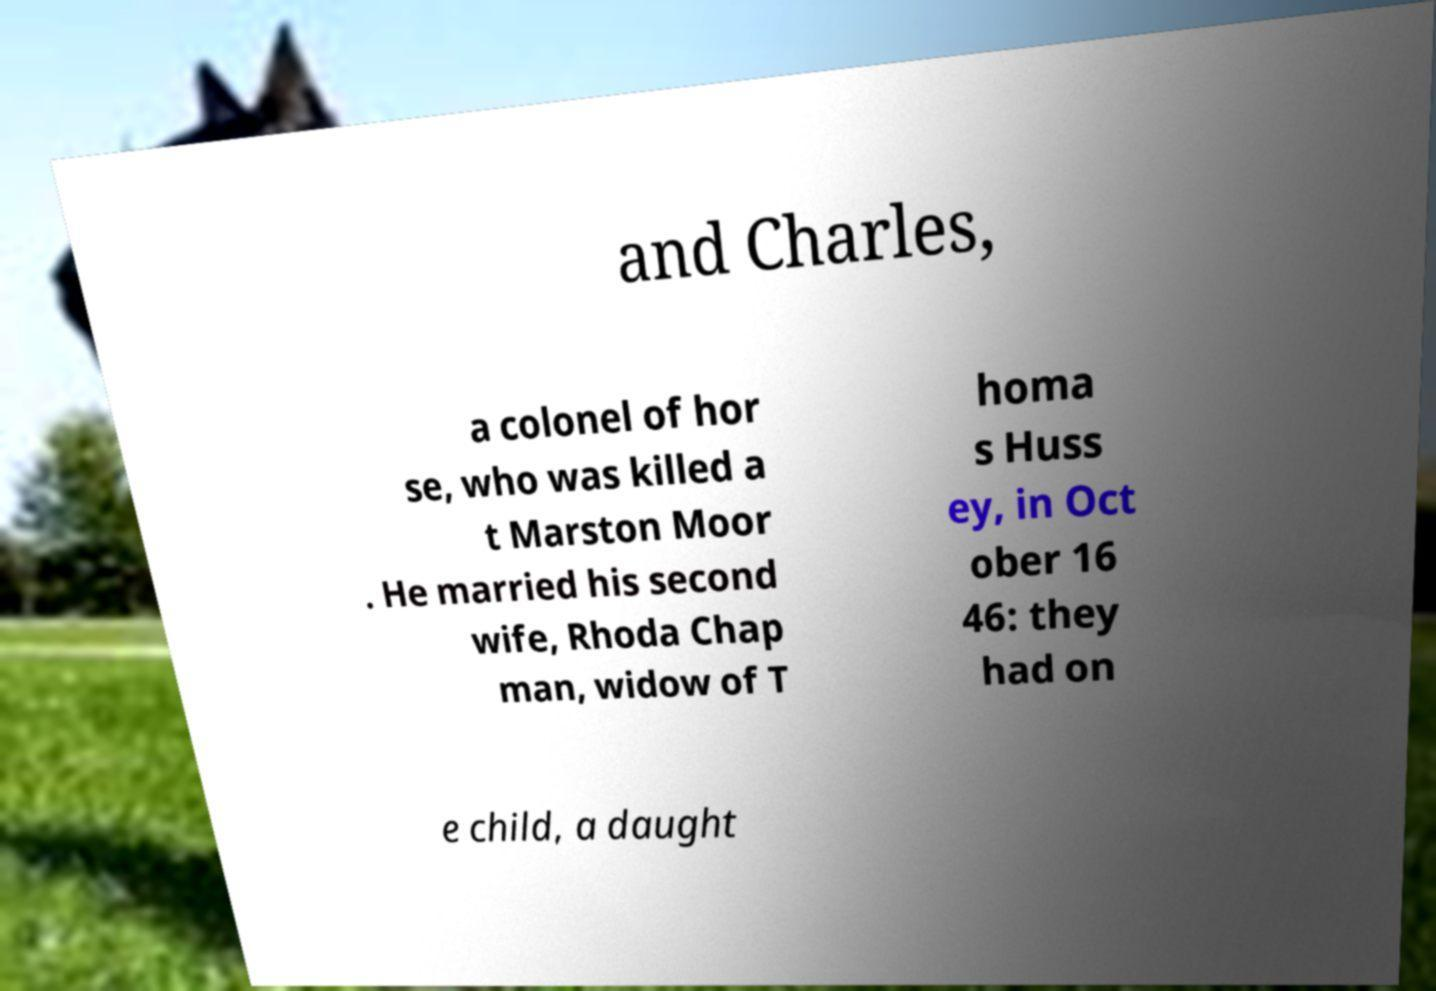Please read and relay the text visible in this image. What does it say? and Charles, a colonel of hor se, who was killed a t Marston Moor . He married his second wife, Rhoda Chap man, widow of T homa s Huss ey, in Oct ober 16 46: they had on e child, a daught 